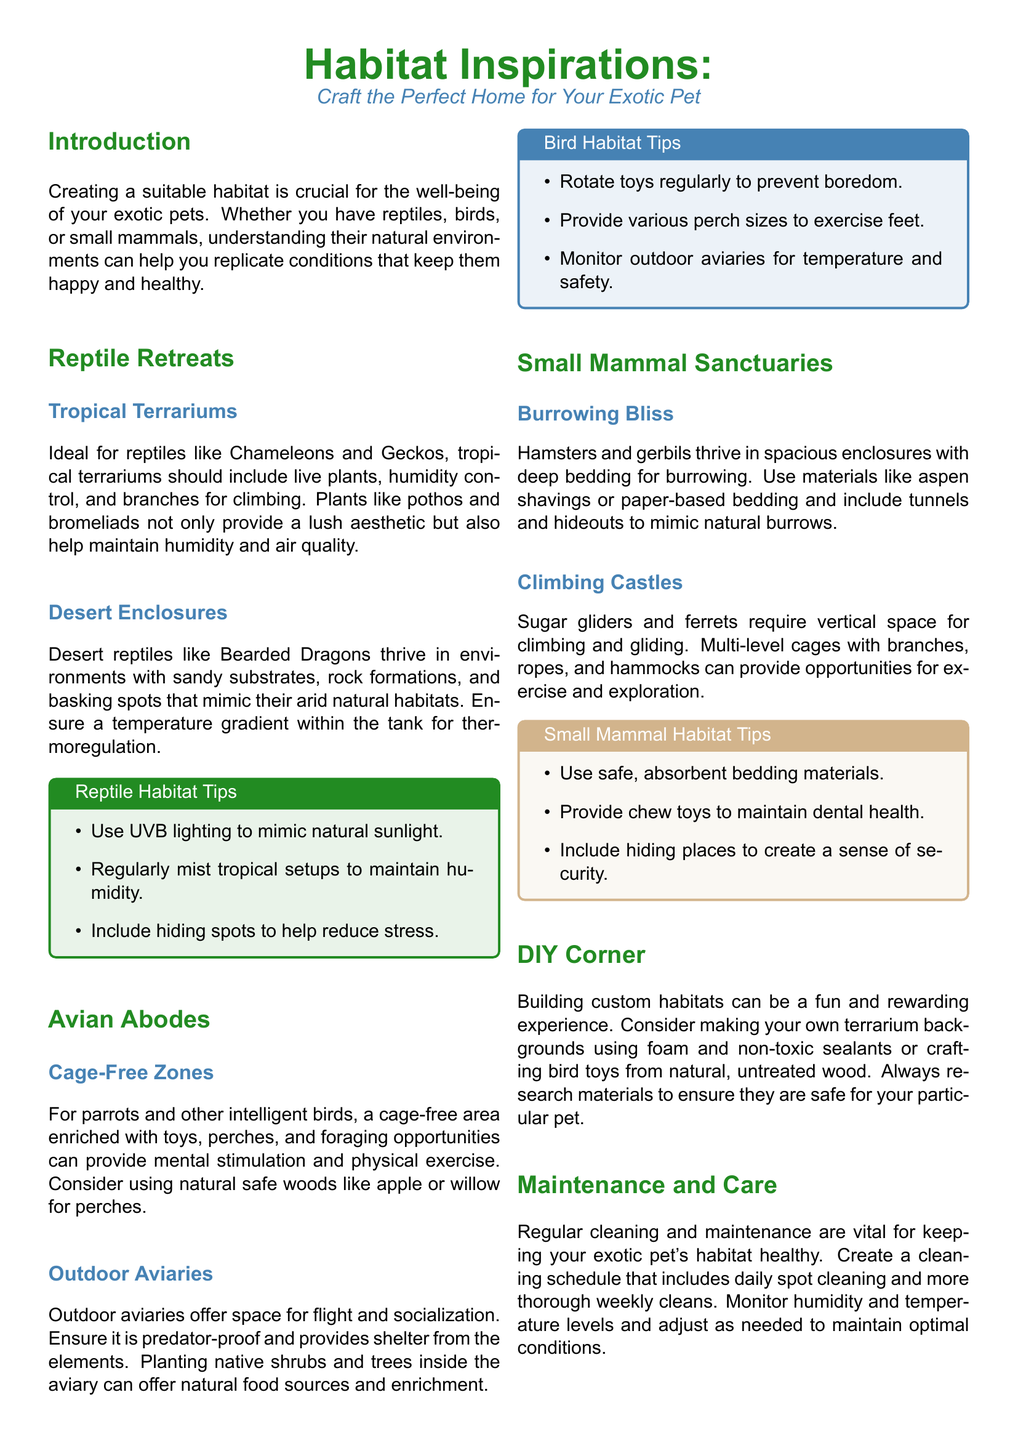What are the key components of a tropical terrarium? The tropical terrarium should include live plants, humidity control, and branches for climbing.
Answer: Live plants, humidity control, and branches for climbing What is a recommended substrate for desert reptiles? The document states that sandy substrates, rock formations, and basking spots should be used.
Answer: Sandy substrates What type of environment is best for small mammals like hamsters? Small mammals like hamsters thrive in spacious enclosures with deep bedding for burrowing.
Answer: Spacious enclosures with deep bedding Which natural materials are suggested for parrot perches? Natural safe woods like apple or willow are recommended.
Answer: Apple or willow How often should toys be rotated for birds? The document advises rotating toys regularly to prevent boredom.
Answer: Regularly What heating element should be used to mimic sunlight for reptiles? UVB lighting is suggested to mimic natural sunlight.
Answer: UVB lighting What kind of bedding is recommended for sugar gliders? The document specifies safe, absorbent bedding materials should be used.
Answer: Safe, absorbent bedding materials What is the primary benefit of providing a habitat that meets pets' needs? It enhances their well-being and enriches their lives.
Answer: Enhances well-being What simple DIY project is suggested for creating habitats? Making your own terrarium backgrounds using foam and non-toxic sealants is suggested.
Answer: Terrarium backgrounds What is the maintenance frequency mentioned for cleaning? A cleaning schedule should include daily spot cleaning and more thorough weekly cleans.
Answer: Daily and weekly 